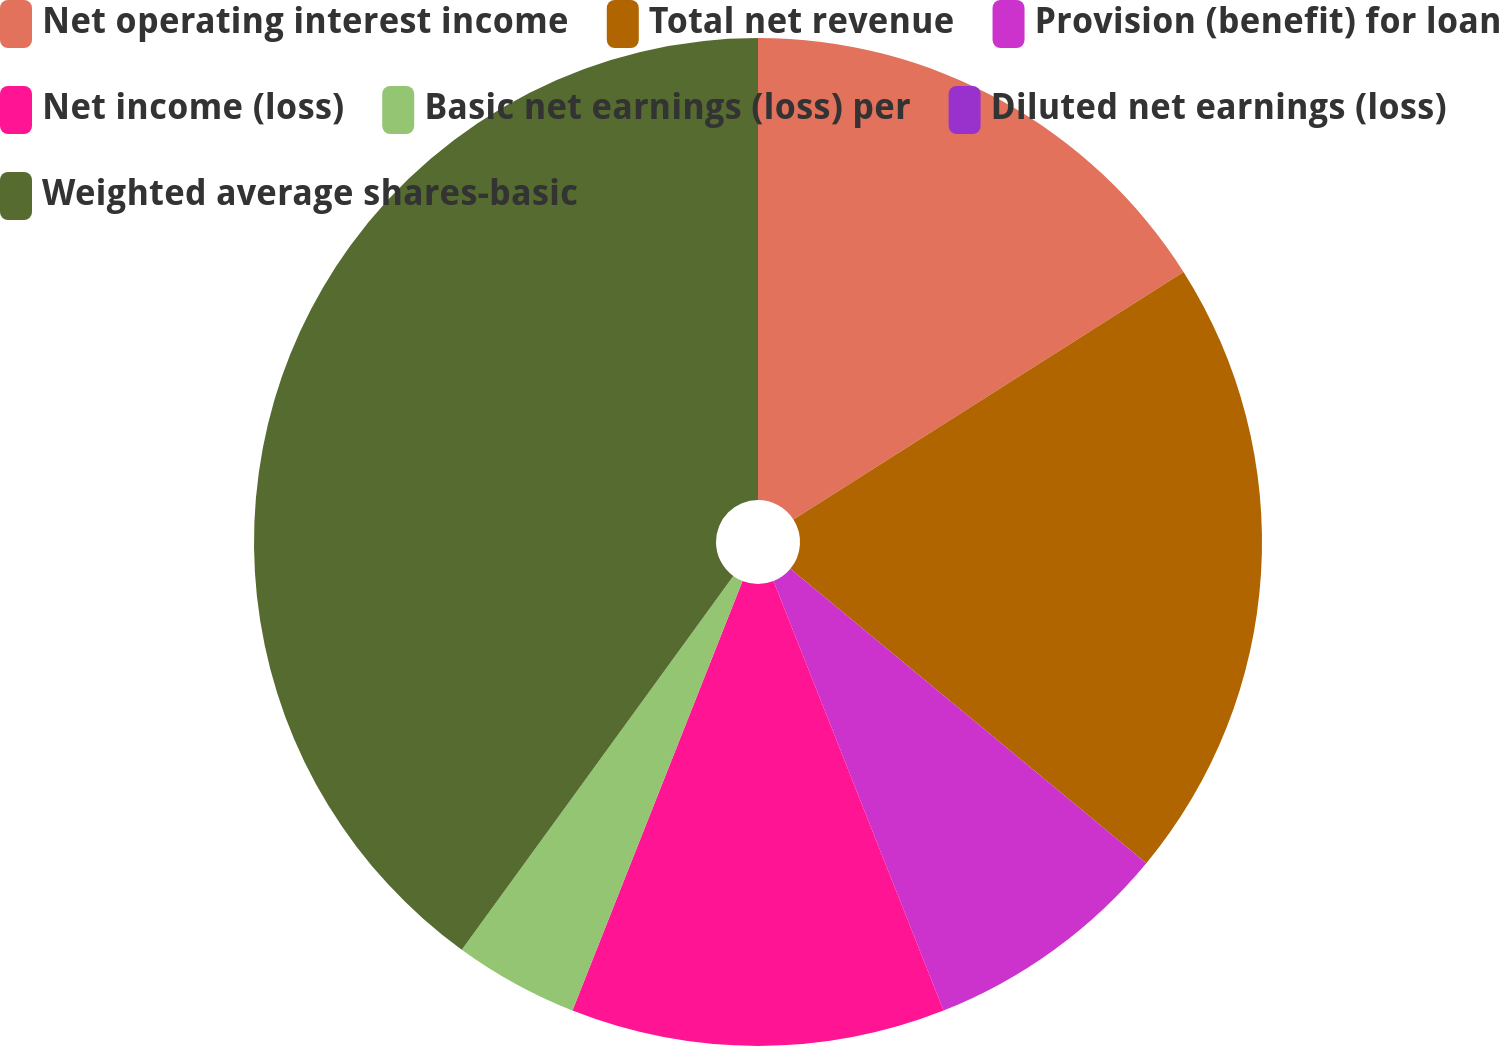Convert chart. <chart><loc_0><loc_0><loc_500><loc_500><pie_chart><fcel>Net operating interest income<fcel>Total net revenue<fcel>Provision (benefit) for loan<fcel>Net income (loss)<fcel>Basic net earnings (loss) per<fcel>Diluted net earnings (loss)<fcel>Weighted average shares-basic<nl><fcel>16.0%<fcel>20.0%<fcel>8.0%<fcel>12.0%<fcel>4.0%<fcel>0.0%<fcel>40.0%<nl></chart> 